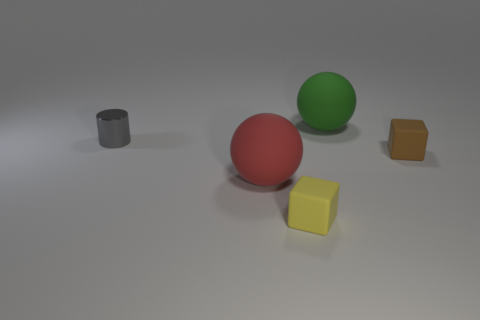Does the block in front of the red object have the same material as the large thing in front of the big green object?
Keep it short and to the point. Yes. Are there fewer tiny brown rubber cubes that are left of the small yellow rubber block than large purple rubber blocks?
Keep it short and to the point. No. What color is the big matte sphere that is in front of the small brown object?
Offer a very short reply. Red. What material is the ball that is in front of the large rubber sphere that is behind the red matte sphere?
Offer a terse response. Rubber. Are there any green rubber spheres of the same size as the brown rubber cube?
Offer a terse response. No. How many objects are big matte spheres to the left of the green matte object or spheres left of the yellow matte object?
Offer a very short reply. 1. There is a metallic object on the left side of the big green sphere; is its size the same as the block right of the big green object?
Your answer should be very brief. Yes. Are there any big matte objects in front of the small cube that is in front of the large red matte sphere?
Your answer should be very brief. No. What number of green matte things are behind the large red object?
Your answer should be very brief. 1. Are there fewer large red rubber things behind the small yellow rubber thing than big red rubber balls behind the gray cylinder?
Keep it short and to the point. No. 